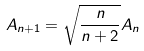Convert formula to latex. <formula><loc_0><loc_0><loc_500><loc_500>A _ { n + 1 } = \sqrt { \frac { n } { n + 2 } } A _ { n }</formula> 